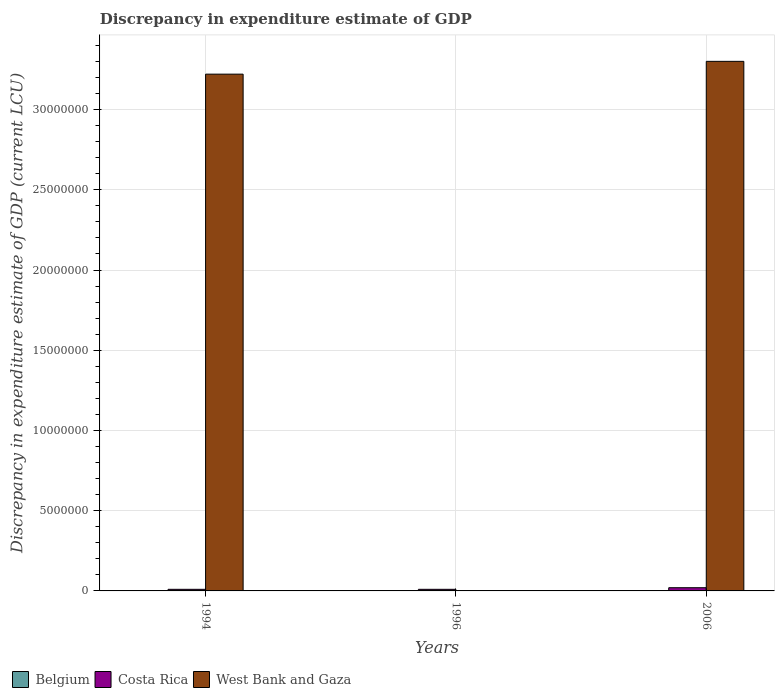How many different coloured bars are there?
Provide a short and direct response. 2. Are the number of bars on each tick of the X-axis equal?
Keep it short and to the point. No. How many bars are there on the 3rd tick from the right?
Your answer should be compact. 2. In how many cases, is the number of bars for a given year not equal to the number of legend labels?
Your answer should be very brief. 3. What is the discrepancy in expenditure estimate of GDP in Costa Rica in 1996?
Give a very brief answer. 1.00e+05. Across all years, what is the maximum discrepancy in expenditure estimate of GDP in Costa Rica?
Ensure brevity in your answer.  2.00e+05. Across all years, what is the minimum discrepancy in expenditure estimate of GDP in West Bank and Gaza?
Offer a terse response. 0. What is the total discrepancy in expenditure estimate of GDP in West Bank and Gaza in the graph?
Your response must be concise. 6.52e+07. What is the difference between the discrepancy in expenditure estimate of GDP in Costa Rica in 1994 and that in 1996?
Offer a very short reply. 0. What is the average discrepancy in expenditure estimate of GDP in Costa Rica per year?
Provide a short and direct response. 1.33e+05. In the year 2006, what is the difference between the discrepancy in expenditure estimate of GDP in Costa Rica and discrepancy in expenditure estimate of GDP in West Bank and Gaza?
Keep it short and to the point. -3.28e+07. What is the ratio of the discrepancy in expenditure estimate of GDP in Costa Rica in 1996 to that in 2006?
Provide a succinct answer. 0.5. Is the discrepancy in expenditure estimate of GDP in Costa Rica in 1994 less than that in 1996?
Your answer should be compact. No. What is the difference between the highest and the lowest discrepancy in expenditure estimate of GDP in Costa Rica?
Your response must be concise. 1.00e+05. In how many years, is the discrepancy in expenditure estimate of GDP in Costa Rica greater than the average discrepancy in expenditure estimate of GDP in Costa Rica taken over all years?
Offer a very short reply. 1. Is it the case that in every year, the sum of the discrepancy in expenditure estimate of GDP in West Bank and Gaza and discrepancy in expenditure estimate of GDP in Costa Rica is greater than the discrepancy in expenditure estimate of GDP in Belgium?
Offer a very short reply. Yes. How many bars are there?
Your answer should be compact. 5. What is the difference between two consecutive major ticks on the Y-axis?
Provide a short and direct response. 5.00e+06. Are the values on the major ticks of Y-axis written in scientific E-notation?
Make the answer very short. No. Does the graph contain any zero values?
Offer a very short reply. Yes. Where does the legend appear in the graph?
Your answer should be very brief. Bottom left. What is the title of the graph?
Offer a very short reply. Discrepancy in expenditure estimate of GDP. What is the label or title of the Y-axis?
Provide a short and direct response. Discrepancy in expenditure estimate of GDP (current LCU). What is the Discrepancy in expenditure estimate of GDP (current LCU) in Belgium in 1994?
Keep it short and to the point. 0. What is the Discrepancy in expenditure estimate of GDP (current LCU) of Costa Rica in 1994?
Your answer should be very brief. 1.00e+05. What is the Discrepancy in expenditure estimate of GDP (current LCU) in West Bank and Gaza in 1994?
Offer a terse response. 3.22e+07. What is the Discrepancy in expenditure estimate of GDP (current LCU) of Belgium in 1996?
Give a very brief answer. 0. What is the Discrepancy in expenditure estimate of GDP (current LCU) in West Bank and Gaza in 1996?
Provide a succinct answer. 0. What is the Discrepancy in expenditure estimate of GDP (current LCU) in Costa Rica in 2006?
Make the answer very short. 2.00e+05. What is the Discrepancy in expenditure estimate of GDP (current LCU) in West Bank and Gaza in 2006?
Give a very brief answer. 3.30e+07. Across all years, what is the maximum Discrepancy in expenditure estimate of GDP (current LCU) of Costa Rica?
Your answer should be very brief. 2.00e+05. Across all years, what is the maximum Discrepancy in expenditure estimate of GDP (current LCU) of West Bank and Gaza?
Provide a short and direct response. 3.30e+07. Across all years, what is the minimum Discrepancy in expenditure estimate of GDP (current LCU) in Costa Rica?
Make the answer very short. 1.00e+05. Across all years, what is the minimum Discrepancy in expenditure estimate of GDP (current LCU) of West Bank and Gaza?
Offer a terse response. 0. What is the total Discrepancy in expenditure estimate of GDP (current LCU) in Costa Rica in the graph?
Provide a short and direct response. 4.00e+05. What is the total Discrepancy in expenditure estimate of GDP (current LCU) of West Bank and Gaza in the graph?
Provide a short and direct response. 6.52e+07. What is the difference between the Discrepancy in expenditure estimate of GDP (current LCU) of Costa Rica in 1994 and that in 1996?
Give a very brief answer. 0. What is the difference between the Discrepancy in expenditure estimate of GDP (current LCU) in West Bank and Gaza in 1994 and that in 2006?
Keep it short and to the point. -7.97e+05. What is the difference between the Discrepancy in expenditure estimate of GDP (current LCU) of Costa Rica in 1994 and the Discrepancy in expenditure estimate of GDP (current LCU) of West Bank and Gaza in 2006?
Provide a short and direct response. -3.29e+07. What is the difference between the Discrepancy in expenditure estimate of GDP (current LCU) of Costa Rica in 1996 and the Discrepancy in expenditure estimate of GDP (current LCU) of West Bank and Gaza in 2006?
Offer a very short reply. -3.29e+07. What is the average Discrepancy in expenditure estimate of GDP (current LCU) in Costa Rica per year?
Give a very brief answer. 1.33e+05. What is the average Discrepancy in expenditure estimate of GDP (current LCU) in West Bank and Gaza per year?
Ensure brevity in your answer.  2.17e+07. In the year 1994, what is the difference between the Discrepancy in expenditure estimate of GDP (current LCU) in Costa Rica and Discrepancy in expenditure estimate of GDP (current LCU) in West Bank and Gaza?
Keep it short and to the point. -3.21e+07. In the year 2006, what is the difference between the Discrepancy in expenditure estimate of GDP (current LCU) of Costa Rica and Discrepancy in expenditure estimate of GDP (current LCU) of West Bank and Gaza?
Offer a very short reply. -3.28e+07. What is the ratio of the Discrepancy in expenditure estimate of GDP (current LCU) of West Bank and Gaza in 1994 to that in 2006?
Offer a terse response. 0.98. What is the difference between the highest and the second highest Discrepancy in expenditure estimate of GDP (current LCU) of Costa Rica?
Make the answer very short. 1.00e+05. What is the difference between the highest and the lowest Discrepancy in expenditure estimate of GDP (current LCU) of Costa Rica?
Your answer should be compact. 1.00e+05. What is the difference between the highest and the lowest Discrepancy in expenditure estimate of GDP (current LCU) in West Bank and Gaza?
Provide a succinct answer. 3.30e+07. 